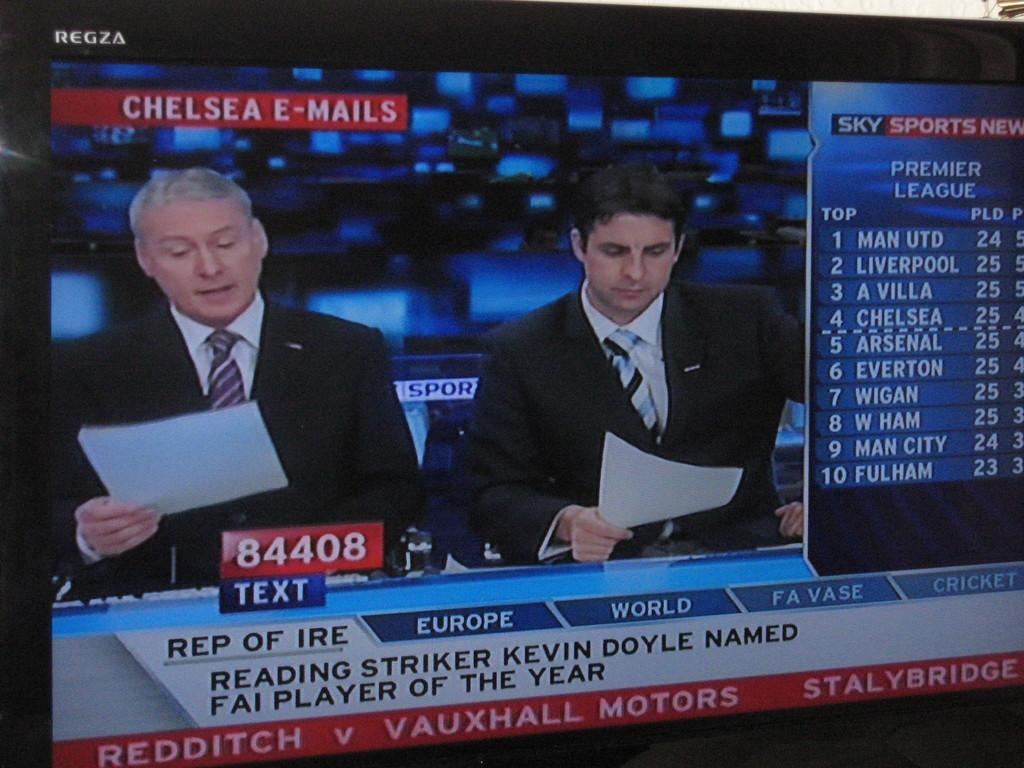Provide a one-sentence caption for the provided image. A news show on the country of Europe is on television. 